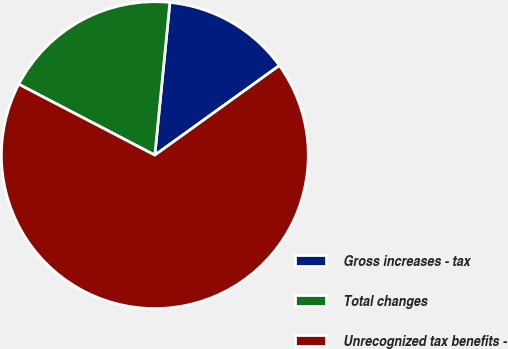<chart> <loc_0><loc_0><loc_500><loc_500><pie_chart><fcel>Gross increases - tax<fcel>Total changes<fcel>Unrecognized tax benefits -<nl><fcel>13.51%<fcel>18.92%<fcel>67.57%<nl></chart> 